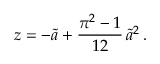Convert formula to latex. <formula><loc_0><loc_0><loc_500><loc_500>z = - \widetilde { a } + \frac { \pi ^ { 2 } - 1 } { 1 2 } \, \widetilde { a } ^ { 2 } \, .</formula> 